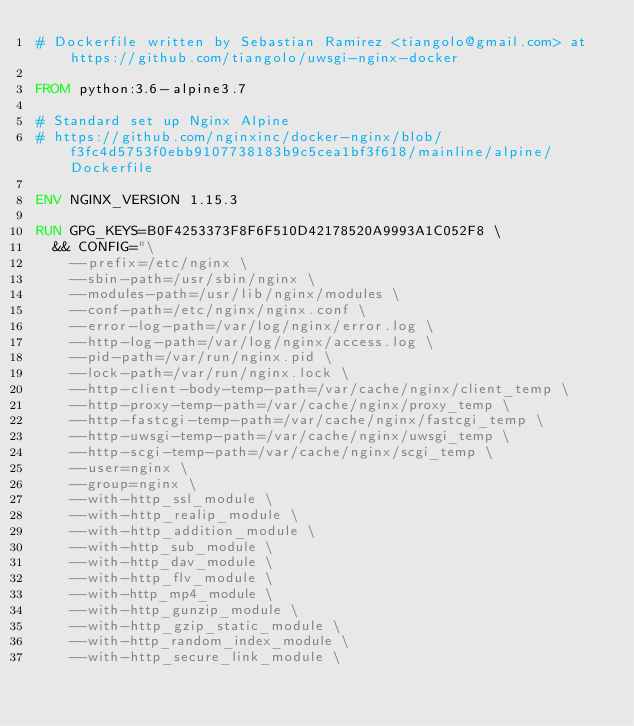<code> <loc_0><loc_0><loc_500><loc_500><_Dockerfile_># Dockerfile written by Sebastian Ramirez <tiangolo@gmail.com> at https://github.com/tiangolo/uwsgi-nginx-docker

FROM python:3.6-alpine3.7

# Standard set up Nginx Alpine
# https://github.com/nginxinc/docker-nginx/blob/f3fc4d5753f0ebb9107738183b9c5cea1bf3f618/mainline/alpine/Dockerfile

ENV NGINX_VERSION 1.15.3

RUN GPG_KEYS=B0F4253373F8F6F510D42178520A9993A1C052F8 \
	&& CONFIG="\
		--prefix=/etc/nginx \
		--sbin-path=/usr/sbin/nginx \
		--modules-path=/usr/lib/nginx/modules \
		--conf-path=/etc/nginx/nginx.conf \
		--error-log-path=/var/log/nginx/error.log \
		--http-log-path=/var/log/nginx/access.log \
		--pid-path=/var/run/nginx.pid \
		--lock-path=/var/run/nginx.lock \
		--http-client-body-temp-path=/var/cache/nginx/client_temp \
		--http-proxy-temp-path=/var/cache/nginx/proxy_temp \
		--http-fastcgi-temp-path=/var/cache/nginx/fastcgi_temp \
		--http-uwsgi-temp-path=/var/cache/nginx/uwsgi_temp \
		--http-scgi-temp-path=/var/cache/nginx/scgi_temp \
		--user=nginx \
		--group=nginx \
		--with-http_ssl_module \
		--with-http_realip_module \
		--with-http_addition_module \
		--with-http_sub_module \
		--with-http_dav_module \
		--with-http_flv_module \
		--with-http_mp4_module \
		--with-http_gunzip_module \
		--with-http_gzip_static_module \
		--with-http_random_index_module \
		--with-http_secure_link_module \</code> 